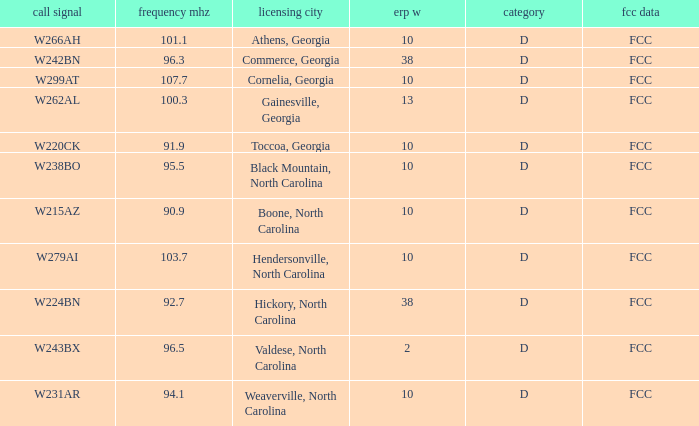Parse the table in full. {'header': ['call signal', 'frequency mhz', 'licensing city', 'erp w', 'category', 'fcc data'], 'rows': [['W266AH', '101.1', 'Athens, Georgia', '10', 'D', 'FCC'], ['W242BN', '96.3', 'Commerce, Georgia', '38', 'D', 'FCC'], ['W299AT', '107.7', 'Cornelia, Georgia', '10', 'D', 'FCC'], ['W262AL', '100.3', 'Gainesville, Georgia', '13', 'D', 'FCC'], ['W220CK', '91.9', 'Toccoa, Georgia', '10', 'D', 'FCC'], ['W238BO', '95.5', 'Black Mountain, North Carolina', '10', 'D', 'FCC'], ['W215AZ', '90.9', 'Boone, North Carolina', '10', 'D', 'FCC'], ['W279AI', '103.7', 'Hendersonville, North Carolina', '10', 'D', 'FCC'], ['W224BN', '92.7', 'Hickory, North Carolina', '38', 'D', 'FCC'], ['W243BX', '96.5', 'Valdese, North Carolina', '2', 'D', 'FCC'], ['W231AR', '94.1', 'Weaverville, North Carolina', '10', 'D', 'FCC']]} What city has larger than 94.1 as a frequency? Athens, Georgia, Commerce, Georgia, Cornelia, Georgia, Gainesville, Georgia, Black Mountain, North Carolina, Hendersonville, North Carolina, Valdese, North Carolina. 